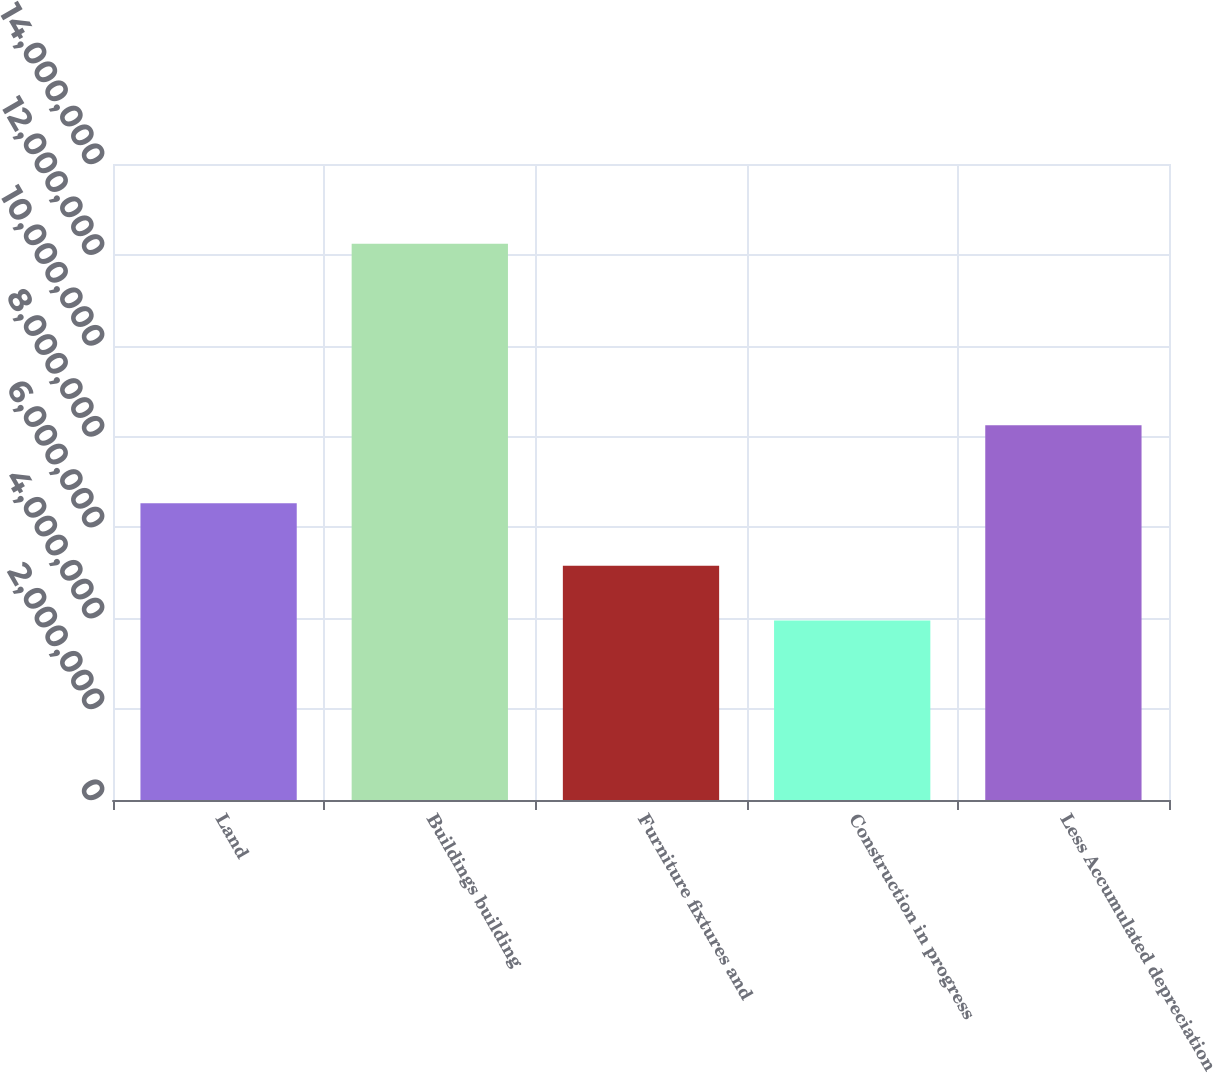Convert chart to OTSL. <chart><loc_0><loc_0><loc_500><loc_500><bar_chart><fcel>Land<fcel>Buildings building<fcel>Furniture fixtures and<fcel>Construction in progress<fcel>Less Accumulated depreciation<nl><fcel>6.5317e+06<fcel>1.2246e+07<fcel>5.15736e+06<fcel>3.95064e+06<fcel>8.25019e+06<nl></chart> 